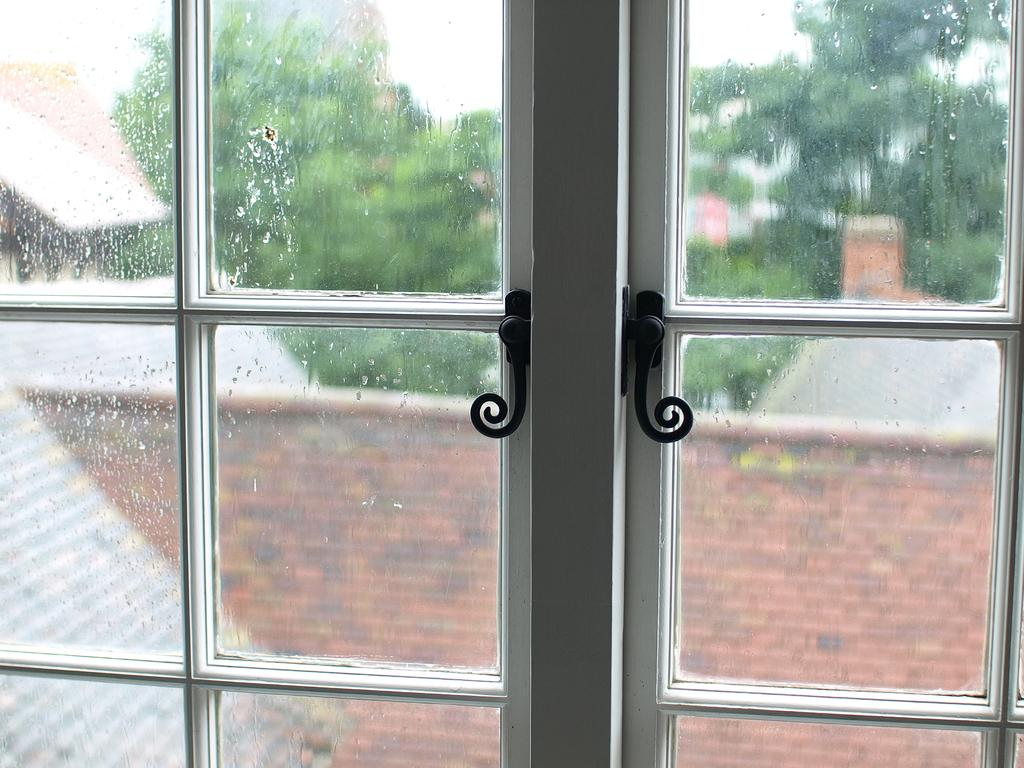What is located in the center of the image? There is a door in the center of the image. What can be seen through the glass of the door? Trees, buildings, and the sky are visible through the glass of the door. What type of cub can be seen in the image? There is no cub present in the image. 